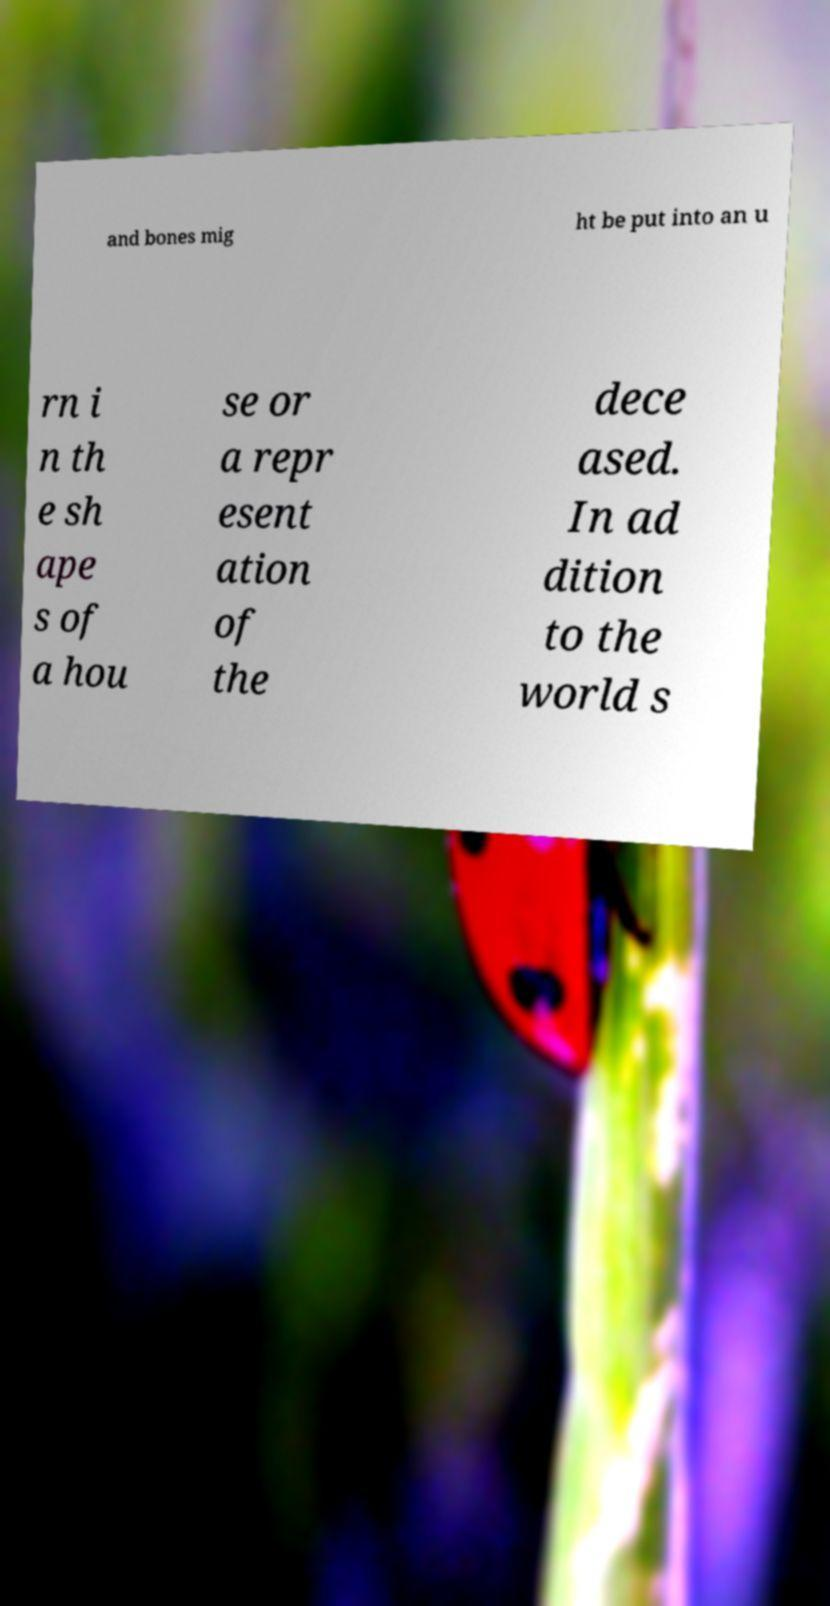I need the written content from this picture converted into text. Can you do that? and bones mig ht be put into an u rn i n th e sh ape s of a hou se or a repr esent ation of the dece ased. In ad dition to the world s 